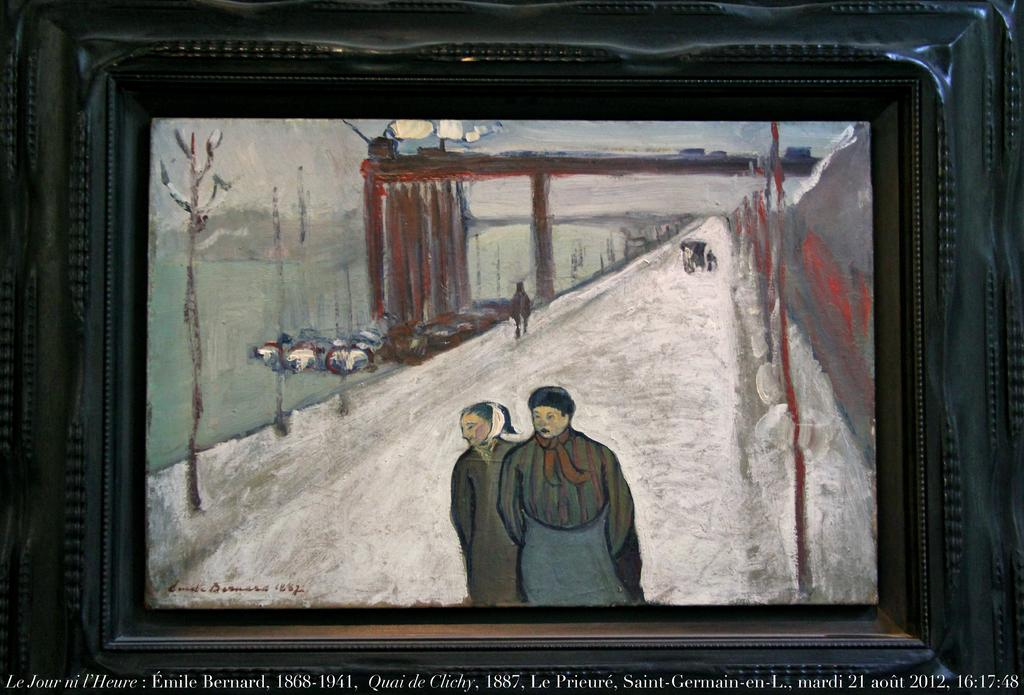<image>
Relay a brief, clear account of the picture shown. a painting of two women on a road with the date 1887 at the bottom 